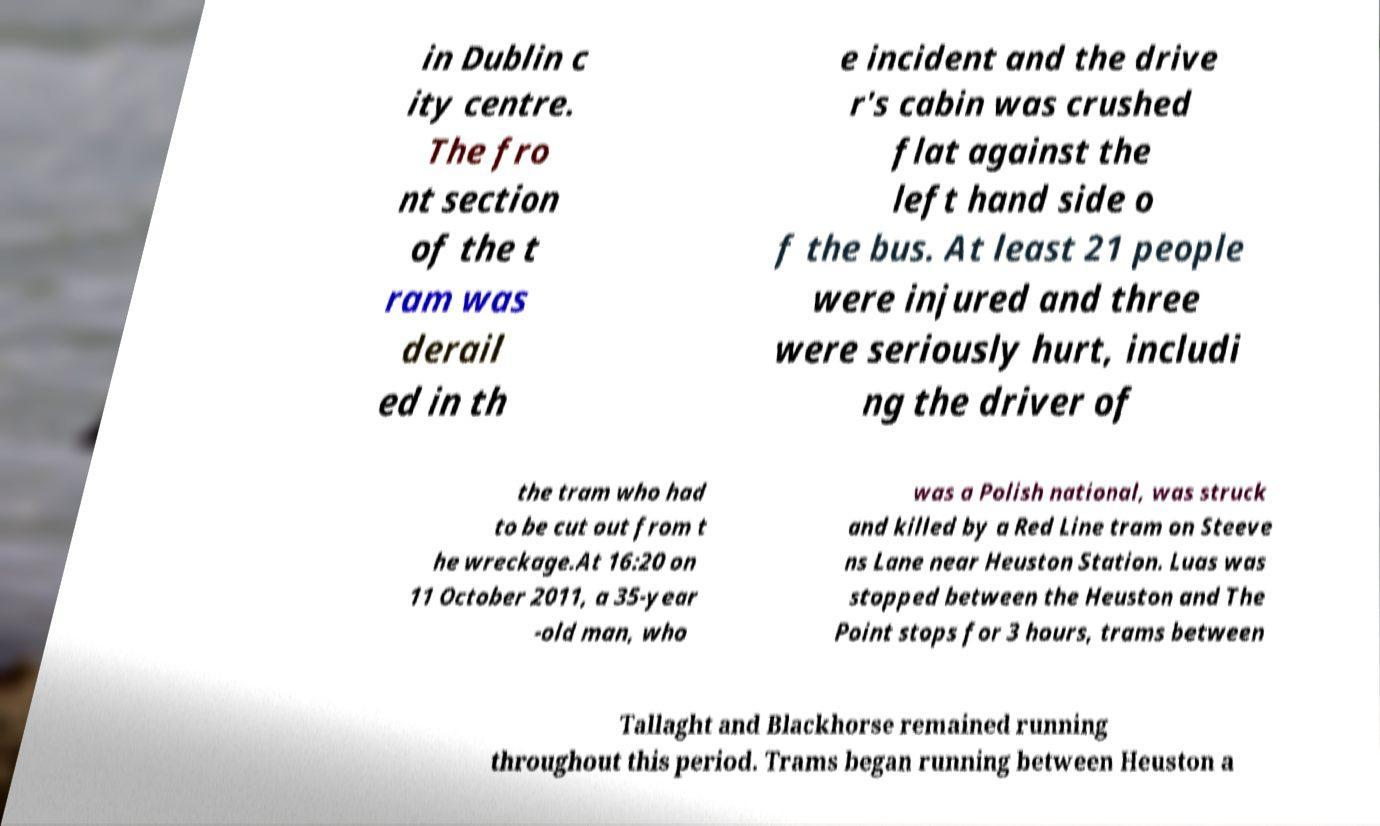I need the written content from this picture converted into text. Can you do that? in Dublin c ity centre. The fro nt section of the t ram was derail ed in th e incident and the drive r's cabin was crushed flat against the left hand side o f the bus. At least 21 people were injured and three were seriously hurt, includi ng the driver of the tram who had to be cut out from t he wreckage.At 16:20 on 11 October 2011, a 35-year -old man, who was a Polish national, was struck and killed by a Red Line tram on Steeve ns Lane near Heuston Station. Luas was stopped between the Heuston and The Point stops for 3 hours, trams between Tallaght and Blackhorse remained running throughout this period. Trams began running between Heuston a 